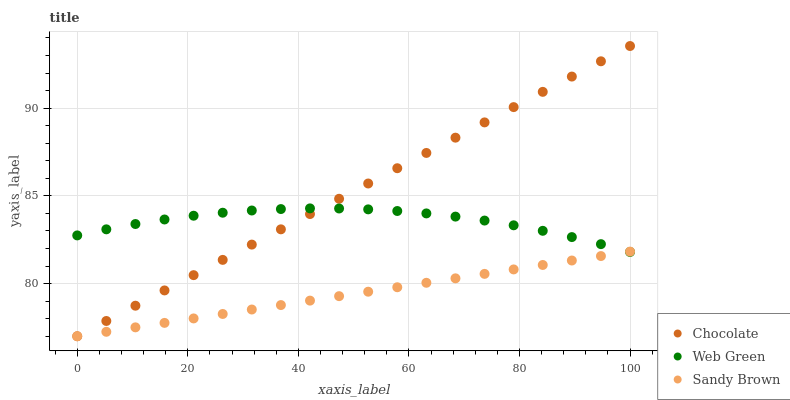Does Sandy Brown have the minimum area under the curve?
Answer yes or no. Yes. Does Chocolate have the maximum area under the curve?
Answer yes or no. Yes. Does Web Green have the minimum area under the curve?
Answer yes or no. No. Does Web Green have the maximum area under the curve?
Answer yes or no. No. Is Chocolate the smoothest?
Answer yes or no. Yes. Is Web Green the roughest?
Answer yes or no. Yes. Is Web Green the smoothest?
Answer yes or no. No. Is Chocolate the roughest?
Answer yes or no. No. Does Sandy Brown have the lowest value?
Answer yes or no. Yes. Does Web Green have the lowest value?
Answer yes or no. No. Does Chocolate have the highest value?
Answer yes or no. Yes. Does Web Green have the highest value?
Answer yes or no. No. Does Web Green intersect Chocolate?
Answer yes or no. Yes. Is Web Green less than Chocolate?
Answer yes or no. No. Is Web Green greater than Chocolate?
Answer yes or no. No. 